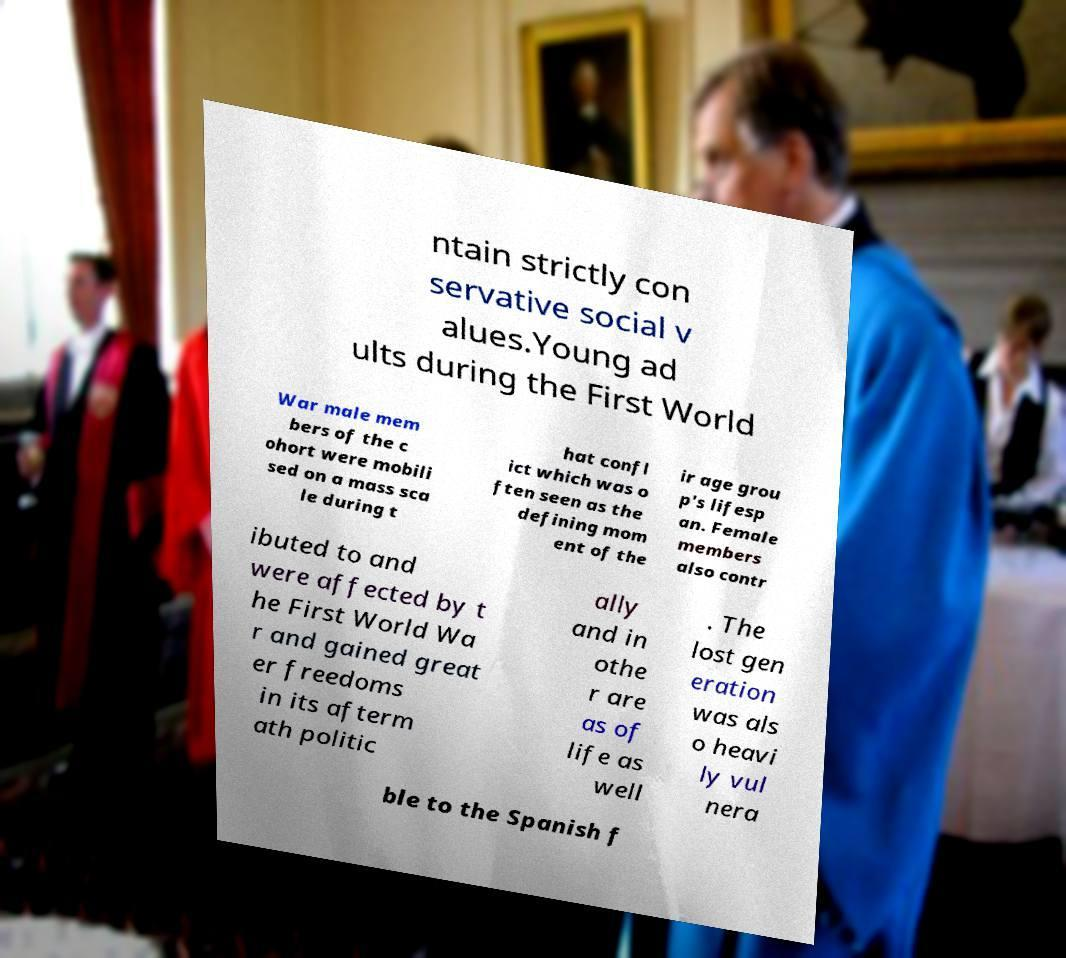Please read and relay the text visible in this image. What does it say? ntain strictly con servative social v alues.Young ad ults during the First World War male mem bers of the c ohort were mobili sed on a mass sca le during t hat confl ict which was o ften seen as the defining mom ent of the ir age grou p's lifesp an. Female members also contr ibuted to and were affected by t he First World Wa r and gained great er freedoms in its afterm ath politic ally and in othe r are as of life as well . The lost gen eration was als o heavi ly vul nera ble to the Spanish f 